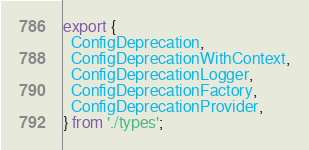<code> <loc_0><loc_0><loc_500><loc_500><_TypeScript_>export {
  ConfigDeprecation,
  ConfigDeprecationWithContext,
  ConfigDeprecationLogger,
  ConfigDeprecationFactory,
  ConfigDeprecationProvider,
} from './types';</code> 